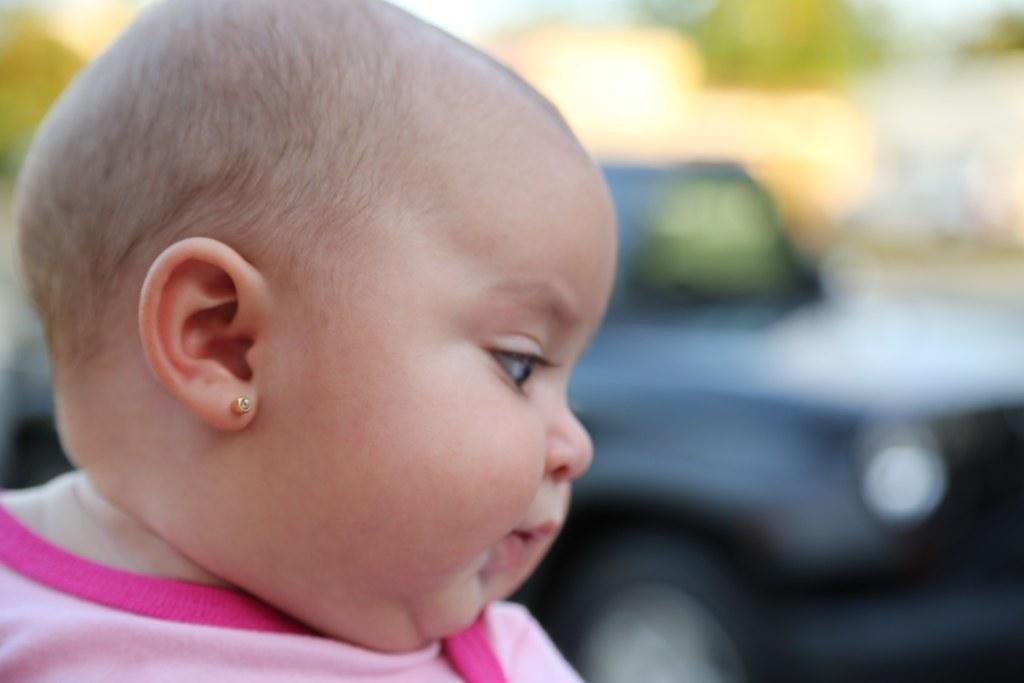How would you summarize this image in a sentence or two? In this picture there is a baby girl who is wearing pink color dress. Here we can see earring. In the back there is a black color car. 